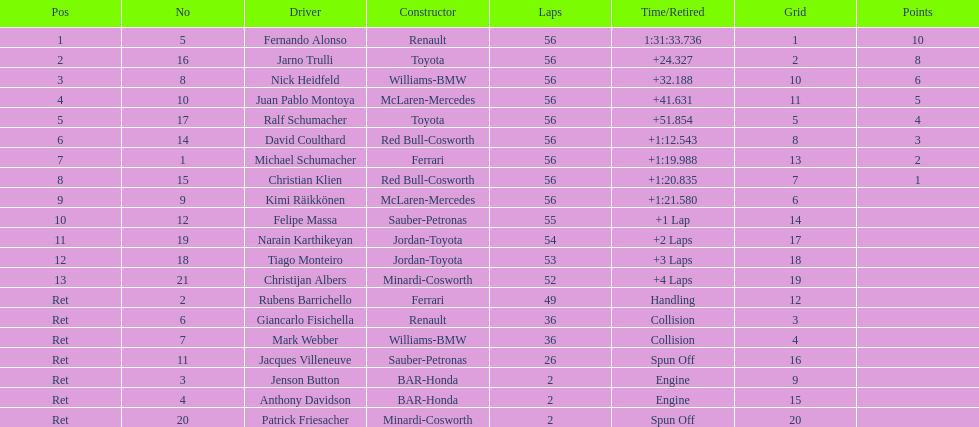Who crossed the finish line before nick heidfeld? Jarno Trulli. 